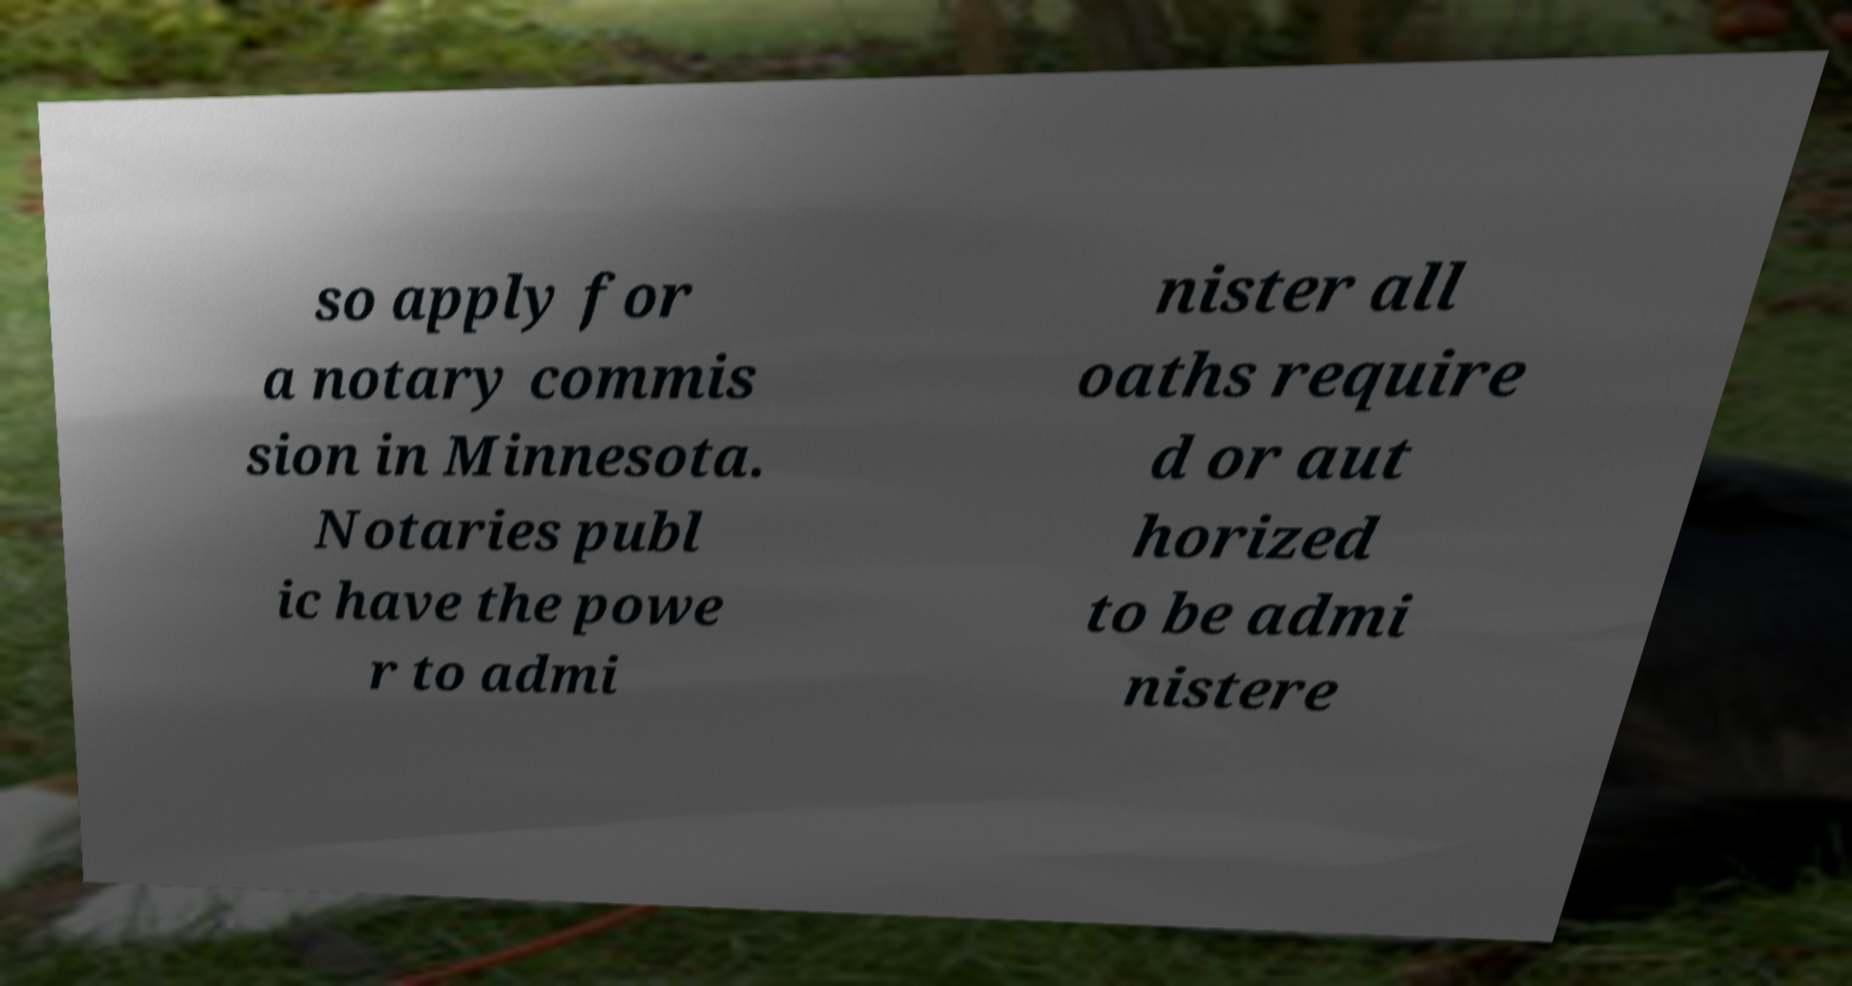Can you read and provide the text displayed in the image?This photo seems to have some interesting text. Can you extract and type it out for me? so apply for a notary commis sion in Minnesota. Notaries publ ic have the powe r to admi nister all oaths require d or aut horized to be admi nistere 